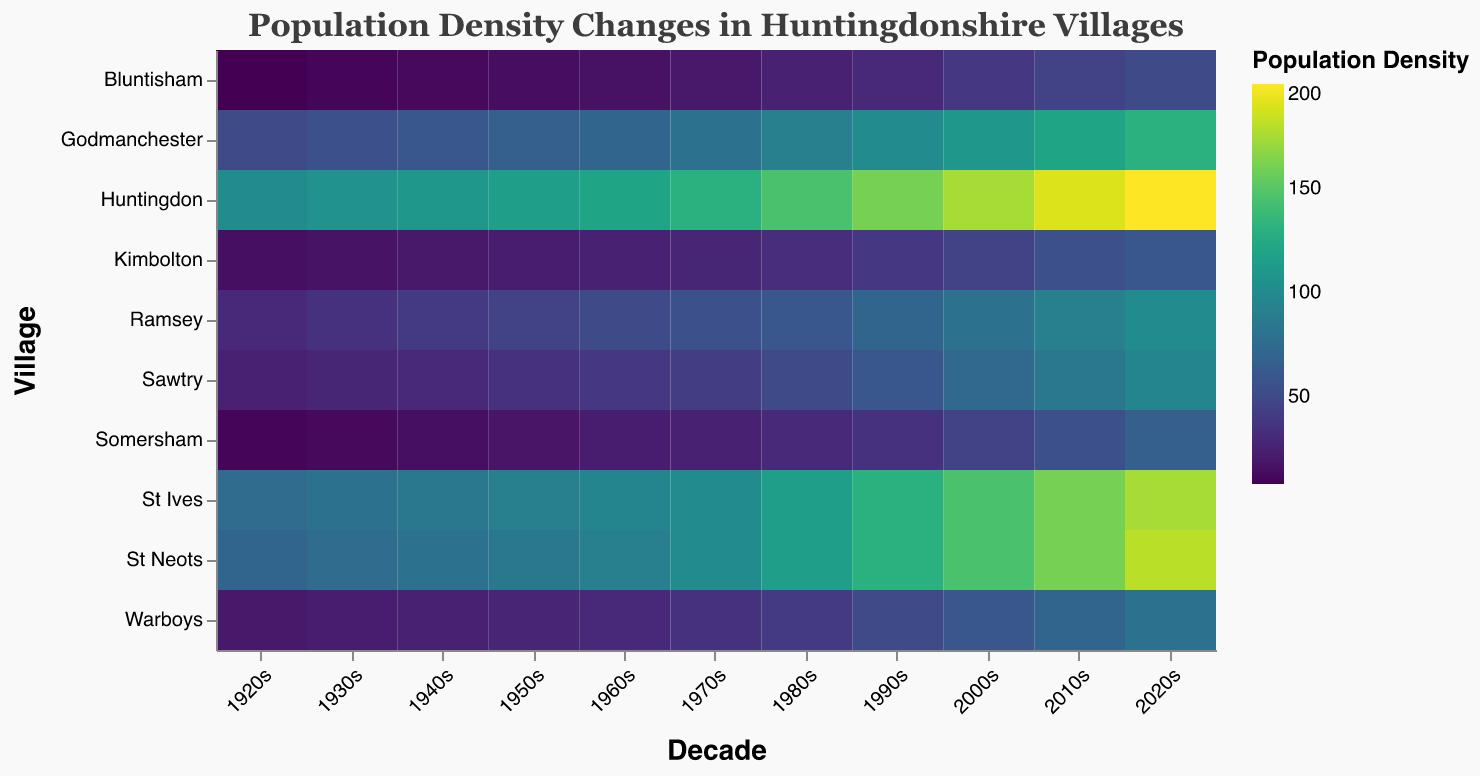Which village had the highest population density in the 2020s? We can observe from the heatmap that the village with the highest color saturation in the 2020s indicates the highest population density.
Answer: Huntingdon Which two decades saw the greatest increase in population density in St Ives? By looking at the color change for St Ives across decades, we can identify the two decades showing the largest change in color intensity.
Answer: 1980s to 1990s and 2000s to 2010s What trend can you see in the population density of Kimbolton from the 1920s to the 2020s? Looking at the color gradient in Kimbolton row from 1920s to 2020s, we see a gradual but steady increase in color intensity. This indicates a consistent increase in population density over time.
Answer: Steady increase Which village had the lowest population density in the 1920s and how did its population density change over the next century? The village with the lowest density in the 1920s is the one with the least intense color in that column. Observing its change over the next decades shows how the shade progresses.
Answer: Bluntisham, it increased steadily In which decade did Sawtry see its population density increase by the highest amount compared to the previous decade? Comparing the color intensity change between each decade for Sawtry, we identify the decade with the sharpest change in color gradient.
Answer: 1980s Comparing the 1940s to the 1950s, which village had the smallest increase in population density? For each village, we can observe the color difference from the 1940s to 1950s to determine the one with the smallest change.
Answer: Bluntisham From the heatmap, which decade shows the most significant overall population growth across all villages? Viewing the color change for all villages between decades, we identify the decade where the color generally becomes more intense across most villages.
Answer: 1990s How does the population growth trend of Warboys compare to that of Ramsey from the 1920s to the 2020s? By comparing the colors in the Warboys and Ramsey rows across multiple decades, we can visually track their growth and identify any similarities or differences in their trends.
Answer: Both show gradual increases, but Ramsey has a more consistent growth rate Which village had the highest percentage increase in population density from the 1920s to the 2020s? Calculate the percentage increase for each village by comparing the values in the 1920s and 2020s columns. The calculation for each village is (2020s value - 1920s value) / 1920s value * 100. The highest percentage identifies the village with the largest increase.
Answer: Sawtry 